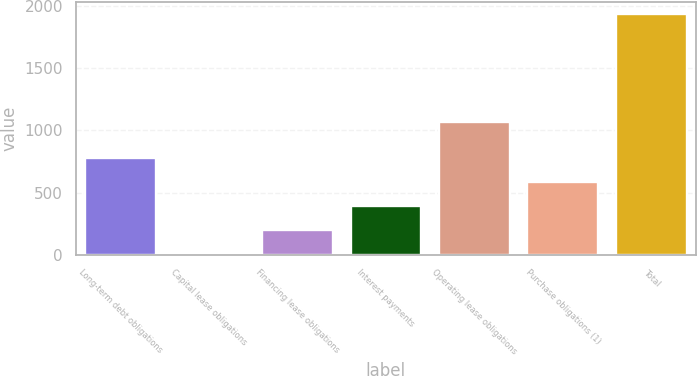Convert chart to OTSL. <chart><loc_0><loc_0><loc_500><loc_500><bar_chart><fcel>Long-term debt obligations<fcel>Capital lease obligations<fcel>Financing lease obligations<fcel>Interest payments<fcel>Operating lease obligations<fcel>Purchase obligations (1)<fcel>Total<nl><fcel>776.4<fcel>4<fcel>197.1<fcel>390.2<fcel>1065<fcel>583.3<fcel>1935<nl></chart> 